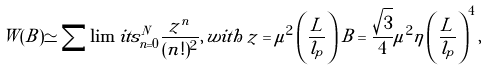Convert formula to latex. <formula><loc_0><loc_0><loc_500><loc_500>W ( B ) \simeq \sum \lim i t s _ { n = 0 } ^ { N } \frac { z ^ { n } } { ( n ! ) ^ { 2 } } , \, w i t h \, z = \mu ^ { 2 } \left ( \frac { L } { l _ { p } } \right ) B = \frac { \sqrt { 3 } } { 4 } \mu ^ { 2 } \eta \left ( \frac { L } { l _ { p } } \right ) ^ { 4 } ,</formula> 